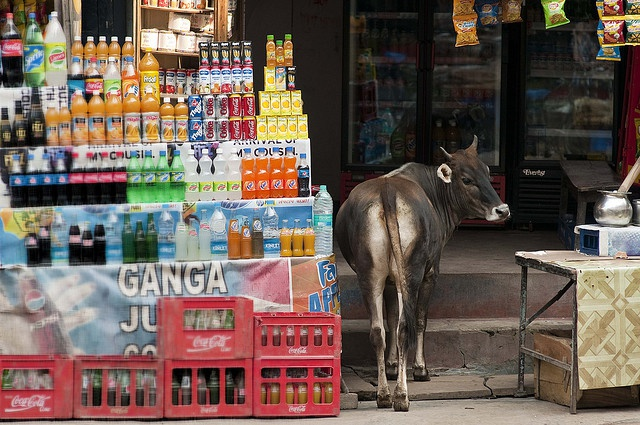Describe the objects in this image and their specific colors. I can see bottle in black, lightgray, darkgray, and gray tones, refrigerator in black and gray tones, cow in black and gray tones, refrigerator in black, gray, and navy tones, and bottle in black, lightgray, beige, and darkgray tones in this image. 